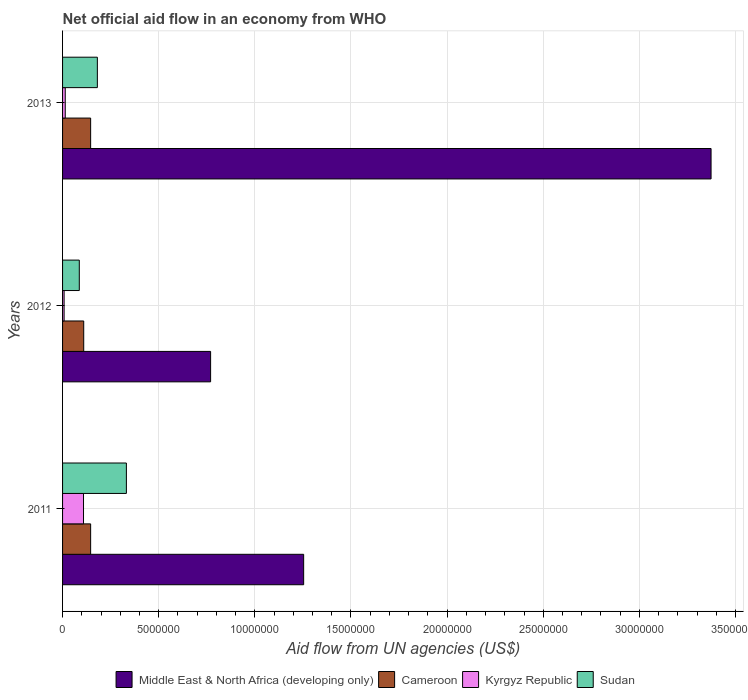Are the number of bars per tick equal to the number of legend labels?
Make the answer very short. Yes. Are the number of bars on each tick of the Y-axis equal?
Offer a terse response. Yes. How many bars are there on the 3rd tick from the bottom?
Give a very brief answer. 4. In how many cases, is the number of bars for a given year not equal to the number of legend labels?
Your answer should be very brief. 0. What is the net official aid flow in Sudan in 2012?
Keep it short and to the point. 8.70e+05. Across all years, what is the maximum net official aid flow in Cameroon?
Offer a very short reply. 1.46e+06. Across all years, what is the minimum net official aid flow in Cameroon?
Offer a terse response. 1.10e+06. In which year was the net official aid flow in Middle East & North Africa (developing only) minimum?
Give a very brief answer. 2012. What is the total net official aid flow in Kyrgyz Republic in the graph?
Make the answer very short. 1.31e+06. What is the difference between the net official aid flow in Kyrgyz Republic in 2011 and that in 2012?
Your response must be concise. 1.01e+06. What is the difference between the net official aid flow in Middle East & North Africa (developing only) in 2013 and the net official aid flow in Kyrgyz Republic in 2012?
Offer a terse response. 3.36e+07. What is the average net official aid flow in Middle East & North Africa (developing only) per year?
Provide a short and direct response. 1.80e+07. In the year 2012, what is the difference between the net official aid flow in Sudan and net official aid flow in Middle East & North Africa (developing only)?
Your answer should be very brief. -6.83e+06. In how many years, is the net official aid flow in Kyrgyz Republic greater than 18000000 US$?
Your answer should be compact. 0. What is the ratio of the net official aid flow in Kyrgyz Republic in 2011 to that in 2013?
Offer a terse response. 7.79. Is the difference between the net official aid flow in Sudan in 2011 and 2013 greater than the difference between the net official aid flow in Middle East & North Africa (developing only) in 2011 and 2013?
Give a very brief answer. Yes. What is the difference between the highest and the lowest net official aid flow in Sudan?
Your answer should be very brief. 2.45e+06. Is the sum of the net official aid flow in Kyrgyz Republic in 2011 and 2012 greater than the maximum net official aid flow in Sudan across all years?
Provide a short and direct response. No. Is it the case that in every year, the sum of the net official aid flow in Middle East & North Africa (developing only) and net official aid flow in Kyrgyz Republic is greater than the sum of net official aid flow in Sudan and net official aid flow in Cameroon?
Your answer should be compact. No. What does the 4th bar from the top in 2012 represents?
Your answer should be very brief. Middle East & North Africa (developing only). What does the 2nd bar from the bottom in 2013 represents?
Provide a succinct answer. Cameroon. How many bars are there?
Keep it short and to the point. 12. Are all the bars in the graph horizontal?
Your answer should be very brief. Yes. How many years are there in the graph?
Make the answer very short. 3. What is the difference between two consecutive major ticks on the X-axis?
Your response must be concise. 5.00e+06. Are the values on the major ticks of X-axis written in scientific E-notation?
Provide a succinct answer. No. How many legend labels are there?
Give a very brief answer. 4. What is the title of the graph?
Offer a very short reply. Net official aid flow in an economy from WHO. What is the label or title of the X-axis?
Your answer should be very brief. Aid flow from UN agencies (US$). What is the Aid flow from UN agencies (US$) of Middle East & North Africa (developing only) in 2011?
Your response must be concise. 1.25e+07. What is the Aid flow from UN agencies (US$) in Cameroon in 2011?
Offer a very short reply. 1.46e+06. What is the Aid flow from UN agencies (US$) in Kyrgyz Republic in 2011?
Make the answer very short. 1.09e+06. What is the Aid flow from UN agencies (US$) of Sudan in 2011?
Give a very brief answer. 3.32e+06. What is the Aid flow from UN agencies (US$) of Middle East & North Africa (developing only) in 2012?
Keep it short and to the point. 7.70e+06. What is the Aid flow from UN agencies (US$) in Cameroon in 2012?
Make the answer very short. 1.10e+06. What is the Aid flow from UN agencies (US$) of Sudan in 2012?
Ensure brevity in your answer.  8.70e+05. What is the Aid flow from UN agencies (US$) in Middle East & North Africa (developing only) in 2013?
Your answer should be compact. 3.37e+07. What is the Aid flow from UN agencies (US$) of Cameroon in 2013?
Your answer should be very brief. 1.46e+06. What is the Aid flow from UN agencies (US$) of Kyrgyz Republic in 2013?
Ensure brevity in your answer.  1.40e+05. What is the Aid flow from UN agencies (US$) in Sudan in 2013?
Your answer should be very brief. 1.81e+06. Across all years, what is the maximum Aid flow from UN agencies (US$) of Middle East & North Africa (developing only)?
Your answer should be compact. 3.37e+07. Across all years, what is the maximum Aid flow from UN agencies (US$) of Cameroon?
Keep it short and to the point. 1.46e+06. Across all years, what is the maximum Aid flow from UN agencies (US$) in Kyrgyz Republic?
Offer a very short reply. 1.09e+06. Across all years, what is the maximum Aid flow from UN agencies (US$) in Sudan?
Keep it short and to the point. 3.32e+06. Across all years, what is the minimum Aid flow from UN agencies (US$) of Middle East & North Africa (developing only)?
Provide a short and direct response. 7.70e+06. Across all years, what is the minimum Aid flow from UN agencies (US$) in Cameroon?
Offer a terse response. 1.10e+06. Across all years, what is the minimum Aid flow from UN agencies (US$) in Kyrgyz Republic?
Keep it short and to the point. 8.00e+04. Across all years, what is the minimum Aid flow from UN agencies (US$) of Sudan?
Your answer should be very brief. 8.70e+05. What is the total Aid flow from UN agencies (US$) of Middle East & North Africa (developing only) in the graph?
Your answer should be very brief. 5.40e+07. What is the total Aid flow from UN agencies (US$) in Cameroon in the graph?
Offer a terse response. 4.02e+06. What is the total Aid flow from UN agencies (US$) in Kyrgyz Republic in the graph?
Provide a succinct answer. 1.31e+06. What is the total Aid flow from UN agencies (US$) of Sudan in the graph?
Ensure brevity in your answer.  6.00e+06. What is the difference between the Aid flow from UN agencies (US$) of Middle East & North Africa (developing only) in 2011 and that in 2012?
Your answer should be compact. 4.84e+06. What is the difference between the Aid flow from UN agencies (US$) of Kyrgyz Republic in 2011 and that in 2012?
Keep it short and to the point. 1.01e+06. What is the difference between the Aid flow from UN agencies (US$) in Sudan in 2011 and that in 2012?
Make the answer very short. 2.45e+06. What is the difference between the Aid flow from UN agencies (US$) in Middle East & North Africa (developing only) in 2011 and that in 2013?
Provide a short and direct response. -2.12e+07. What is the difference between the Aid flow from UN agencies (US$) of Kyrgyz Republic in 2011 and that in 2013?
Give a very brief answer. 9.50e+05. What is the difference between the Aid flow from UN agencies (US$) of Sudan in 2011 and that in 2013?
Your response must be concise. 1.51e+06. What is the difference between the Aid flow from UN agencies (US$) of Middle East & North Africa (developing only) in 2012 and that in 2013?
Keep it short and to the point. -2.60e+07. What is the difference between the Aid flow from UN agencies (US$) of Cameroon in 2012 and that in 2013?
Provide a short and direct response. -3.60e+05. What is the difference between the Aid flow from UN agencies (US$) in Sudan in 2012 and that in 2013?
Offer a terse response. -9.40e+05. What is the difference between the Aid flow from UN agencies (US$) in Middle East & North Africa (developing only) in 2011 and the Aid flow from UN agencies (US$) in Cameroon in 2012?
Give a very brief answer. 1.14e+07. What is the difference between the Aid flow from UN agencies (US$) of Middle East & North Africa (developing only) in 2011 and the Aid flow from UN agencies (US$) of Kyrgyz Republic in 2012?
Give a very brief answer. 1.25e+07. What is the difference between the Aid flow from UN agencies (US$) of Middle East & North Africa (developing only) in 2011 and the Aid flow from UN agencies (US$) of Sudan in 2012?
Your response must be concise. 1.17e+07. What is the difference between the Aid flow from UN agencies (US$) in Cameroon in 2011 and the Aid flow from UN agencies (US$) in Kyrgyz Republic in 2012?
Your answer should be compact. 1.38e+06. What is the difference between the Aid flow from UN agencies (US$) in Cameroon in 2011 and the Aid flow from UN agencies (US$) in Sudan in 2012?
Provide a succinct answer. 5.90e+05. What is the difference between the Aid flow from UN agencies (US$) of Kyrgyz Republic in 2011 and the Aid flow from UN agencies (US$) of Sudan in 2012?
Your answer should be very brief. 2.20e+05. What is the difference between the Aid flow from UN agencies (US$) of Middle East & North Africa (developing only) in 2011 and the Aid flow from UN agencies (US$) of Cameroon in 2013?
Your answer should be compact. 1.11e+07. What is the difference between the Aid flow from UN agencies (US$) in Middle East & North Africa (developing only) in 2011 and the Aid flow from UN agencies (US$) in Kyrgyz Republic in 2013?
Ensure brevity in your answer.  1.24e+07. What is the difference between the Aid flow from UN agencies (US$) of Middle East & North Africa (developing only) in 2011 and the Aid flow from UN agencies (US$) of Sudan in 2013?
Give a very brief answer. 1.07e+07. What is the difference between the Aid flow from UN agencies (US$) in Cameroon in 2011 and the Aid flow from UN agencies (US$) in Kyrgyz Republic in 2013?
Give a very brief answer. 1.32e+06. What is the difference between the Aid flow from UN agencies (US$) in Cameroon in 2011 and the Aid flow from UN agencies (US$) in Sudan in 2013?
Give a very brief answer. -3.50e+05. What is the difference between the Aid flow from UN agencies (US$) in Kyrgyz Republic in 2011 and the Aid flow from UN agencies (US$) in Sudan in 2013?
Offer a very short reply. -7.20e+05. What is the difference between the Aid flow from UN agencies (US$) in Middle East & North Africa (developing only) in 2012 and the Aid flow from UN agencies (US$) in Cameroon in 2013?
Your response must be concise. 6.24e+06. What is the difference between the Aid flow from UN agencies (US$) in Middle East & North Africa (developing only) in 2012 and the Aid flow from UN agencies (US$) in Kyrgyz Republic in 2013?
Provide a succinct answer. 7.56e+06. What is the difference between the Aid flow from UN agencies (US$) of Middle East & North Africa (developing only) in 2012 and the Aid flow from UN agencies (US$) of Sudan in 2013?
Your answer should be very brief. 5.89e+06. What is the difference between the Aid flow from UN agencies (US$) of Cameroon in 2012 and the Aid flow from UN agencies (US$) of Kyrgyz Republic in 2013?
Your answer should be very brief. 9.60e+05. What is the difference between the Aid flow from UN agencies (US$) of Cameroon in 2012 and the Aid flow from UN agencies (US$) of Sudan in 2013?
Make the answer very short. -7.10e+05. What is the difference between the Aid flow from UN agencies (US$) of Kyrgyz Republic in 2012 and the Aid flow from UN agencies (US$) of Sudan in 2013?
Provide a succinct answer. -1.73e+06. What is the average Aid flow from UN agencies (US$) of Middle East & North Africa (developing only) per year?
Give a very brief answer. 1.80e+07. What is the average Aid flow from UN agencies (US$) of Cameroon per year?
Give a very brief answer. 1.34e+06. What is the average Aid flow from UN agencies (US$) of Kyrgyz Republic per year?
Make the answer very short. 4.37e+05. What is the average Aid flow from UN agencies (US$) of Sudan per year?
Make the answer very short. 2.00e+06. In the year 2011, what is the difference between the Aid flow from UN agencies (US$) of Middle East & North Africa (developing only) and Aid flow from UN agencies (US$) of Cameroon?
Make the answer very short. 1.11e+07. In the year 2011, what is the difference between the Aid flow from UN agencies (US$) in Middle East & North Africa (developing only) and Aid flow from UN agencies (US$) in Kyrgyz Republic?
Offer a terse response. 1.14e+07. In the year 2011, what is the difference between the Aid flow from UN agencies (US$) in Middle East & North Africa (developing only) and Aid flow from UN agencies (US$) in Sudan?
Make the answer very short. 9.22e+06. In the year 2011, what is the difference between the Aid flow from UN agencies (US$) in Cameroon and Aid flow from UN agencies (US$) in Kyrgyz Republic?
Offer a terse response. 3.70e+05. In the year 2011, what is the difference between the Aid flow from UN agencies (US$) in Cameroon and Aid flow from UN agencies (US$) in Sudan?
Offer a terse response. -1.86e+06. In the year 2011, what is the difference between the Aid flow from UN agencies (US$) in Kyrgyz Republic and Aid flow from UN agencies (US$) in Sudan?
Offer a terse response. -2.23e+06. In the year 2012, what is the difference between the Aid flow from UN agencies (US$) of Middle East & North Africa (developing only) and Aid flow from UN agencies (US$) of Cameroon?
Your answer should be compact. 6.60e+06. In the year 2012, what is the difference between the Aid flow from UN agencies (US$) of Middle East & North Africa (developing only) and Aid flow from UN agencies (US$) of Kyrgyz Republic?
Offer a terse response. 7.62e+06. In the year 2012, what is the difference between the Aid flow from UN agencies (US$) in Middle East & North Africa (developing only) and Aid flow from UN agencies (US$) in Sudan?
Provide a succinct answer. 6.83e+06. In the year 2012, what is the difference between the Aid flow from UN agencies (US$) in Cameroon and Aid flow from UN agencies (US$) in Kyrgyz Republic?
Offer a terse response. 1.02e+06. In the year 2012, what is the difference between the Aid flow from UN agencies (US$) of Cameroon and Aid flow from UN agencies (US$) of Sudan?
Your answer should be very brief. 2.30e+05. In the year 2012, what is the difference between the Aid flow from UN agencies (US$) in Kyrgyz Republic and Aid flow from UN agencies (US$) in Sudan?
Provide a short and direct response. -7.90e+05. In the year 2013, what is the difference between the Aid flow from UN agencies (US$) in Middle East & North Africa (developing only) and Aid flow from UN agencies (US$) in Cameroon?
Offer a very short reply. 3.23e+07. In the year 2013, what is the difference between the Aid flow from UN agencies (US$) of Middle East & North Africa (developing only) and Aid flow from UN agencies (US$) of Kyrgyz Republic?
Make the answer very short. 3.36e+07. In the year 2013, what is the difference between the Aid flow from UN agencies (US$) of Middle East & North Africa (developing only) and Aid flow from UN agencies (US$) of Sudan?
Make the answer very short. 3.19e+07. In the year 2013, what is the difference between the Aid flow from UN agencies (US$) in Cameroon and Aid flow from UN agencies (US$) in Kyrgyz Republic?
Your answer should be very brief. 1.32e+06. In the year 2013, what is the difference between the Aid flow from UN agencies (US$) in Cameroon and Aid flow from UN agencies (US$) in Sudan?
Offer a terse response. -3.50e+05. In the year 2013, what is the difference between the Aid flow from UN agencies (US$) of Kyrgyz Republic and Aid flow from UN agencies (US$) of Sudan?
Your answer should be compact. -1.67e+06. What is the ratio of the Aid flow from UN agencies (US$) in Middle East & North Africa (developing only) in 2011 to that in 2012?
Make the answer very short. 1.63. What is the ratio of the Aid flow from UN agencies (US$) of Cameroon in 2011 to that in 2012?
Your answer should be compact. 1.33. What is the ratio of the Aid flow from UN agencies (US$) of Kyrgyz Republic in 2011 to that in 2012?
Your answer should be very brief. 13.62. What is the ratio of the Aid flow from UN agencies (US$) in Sudan in 2011 to that in 2012?
Your answer should be very brief. 3.82. What is the ratio of the Aid flow from UN agencies (US$) of Middle East & North Africa (developing only) in 2011 to that in 2013?
Provide a short and direct response. 0.37. What is the ratio of the Aid flow from UN agencies (US$) in Cameroon in 2011 to that in 2013?
Give a very brief answer. 1. What is the ratio of the Aid flow from UN agencies (US$) of Kyrgyz Republic in 2011 to that in 2013?
Provide a short and direct response. 7.79. What is the ratio of the Aid flow from UN agencies (US$) of Sudan in 2011 to that in 2013?
Offer a very short reply. 1.83. What is the ratio of the Aid flow from UN agencies (US$) of Middle East & North Africa (developing only) in 2012 to that in 2013?
Offer a very short reply. 0.23. What is the ratio of the Aid flow from UN agencies (US$) in Cameroon in 2012 to that in 2013?
Ensure brevity in your answer.  0.75. What is the ratio of the Aid flow from UN agencies (US$) of Kyrgyz Republic in 2012 to that in 2013?
Keep it short and to the point. 0.57. What is the ratio of the Aid flow from UN agencies (US$) of Sudan in 2012 to that in 2013?
Your answer should be very brief. 0.48. What is the difference between the highest and the second highest Aid flow from UN agencies (US$) in Middle East & North Africa (developing only)?
Offer a very short reply. 2.12e+07. What is the difference between the highest and the second highest Aid flow from UN agencies (US$) of Kyrgyz Republic?
Your answer should be very brief. 9.50e+05. What is the difference between the highest and the second highest Aid flow from UN agencies (US$) in Sudan?
Your answer should be compact. 1.51e+06. What is the difference between the highest and the lowest Aid flow from UN agencies (US$) in Middle East & North Africa (developing only)?
Give a very brief answer. 2.60e+07. What is the difference between the highest and the lowest Aid flow from UN agencies (US$) in Cameroon?
Your answer should be very brief. 3.60e+05. What is the difference between the highest and the lowest Aid flow from UN agencies (US$) in Kyrgyz Republic?
Your response must be concise. 1.01e+06. What is the difference between the highest and the lowest Aid flow from UN agencies (US$) of Sudan?
Give a very brief answer. 2.45e+06. 